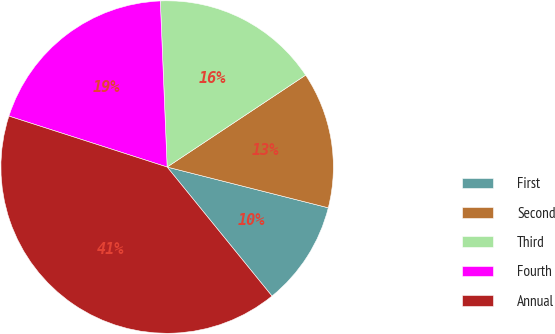<chart> <loc_0><loc_0><loc_500><loc_500><pie_chart><fcel>First<fcel>Second<fcel>Third<fcel>Fourth<fcel>Annual<nl><fcel>10.2%<fcel>13.27%<fcel>16.33%<fcel>19.39%<fcel>40.82%<nl></chart> 